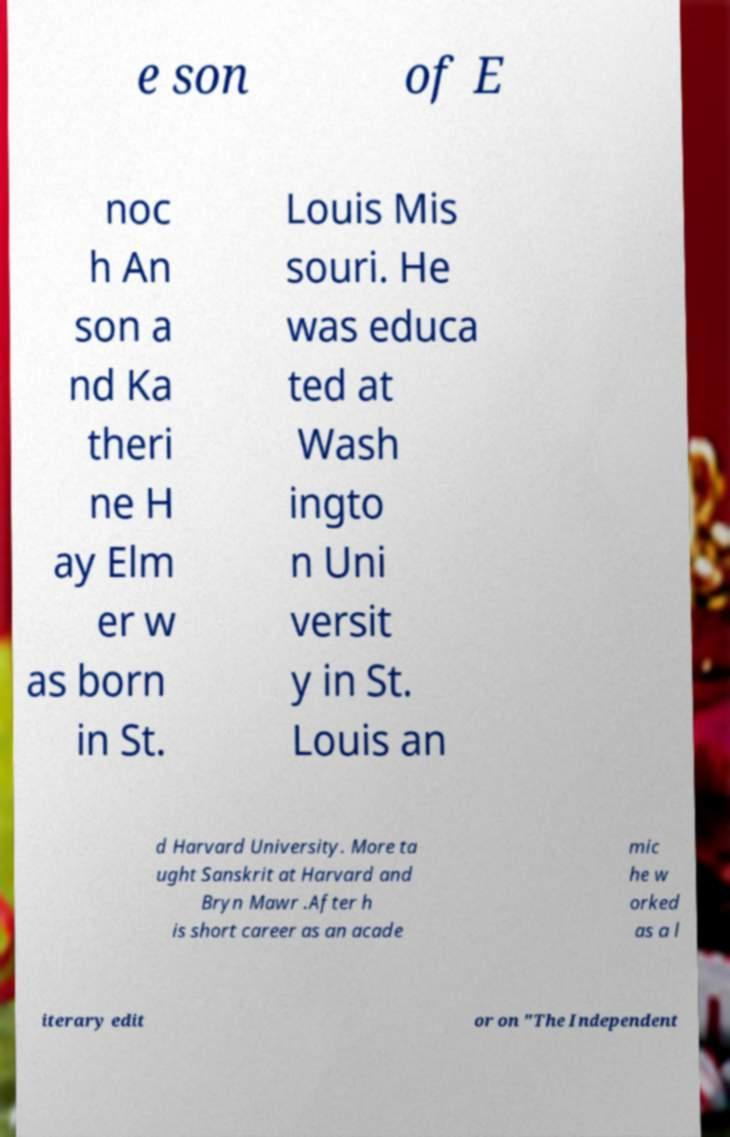Could you assist in decoding the text presented in this image and type it out clearly? e son of E noc h An son a nd Ka theri ne H ay Elm er w as born in St. Louis Mis souri. He was educa ted at Wash ingto n Uni versit y in St. Louis an d Harvard University. More ta ught Sanskrit at Harvard and Bryn Mawr .After h is short career as an acade mic he w orked as a l iterary edit or on "The Independent 